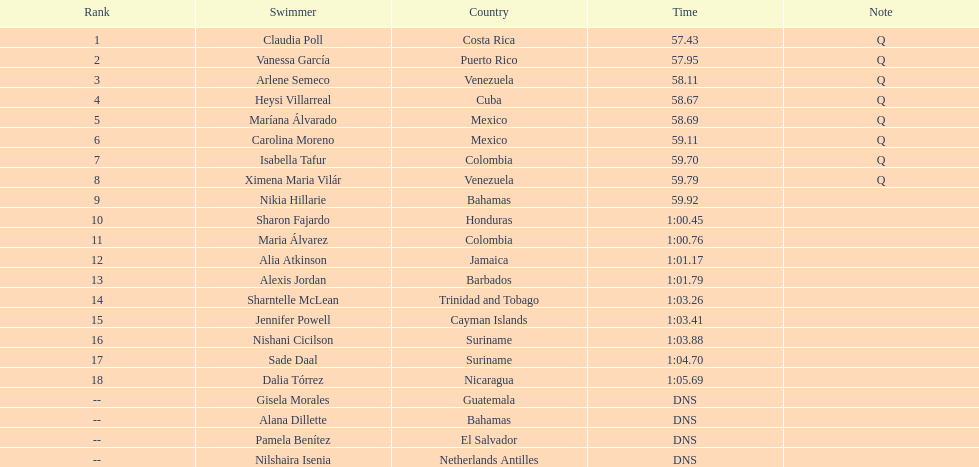Who was the only individual from cuba to secure a position in the top eight? Heysi Villarreal. 